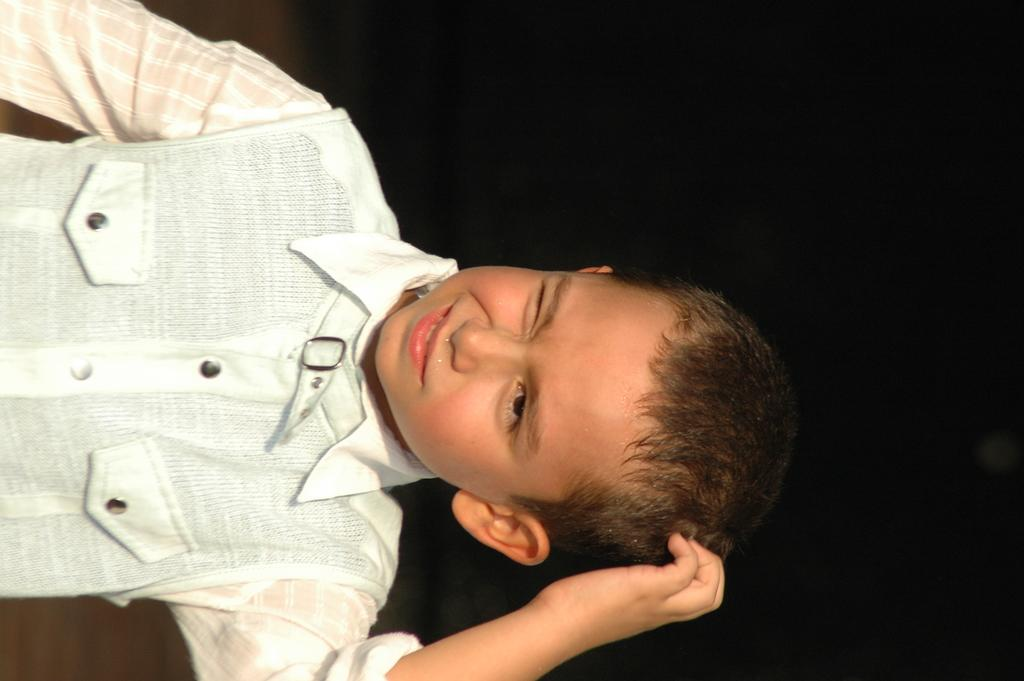What is the color of the background in the image? The background of the image is dark. Where is the kid located in the image? The kid is on the left side of the image. What type of jelly can be seen on the judge's stocking in the image? There is no judge or stocking present in the image, and therefore no jelly can be seen on a judge's stocking. 